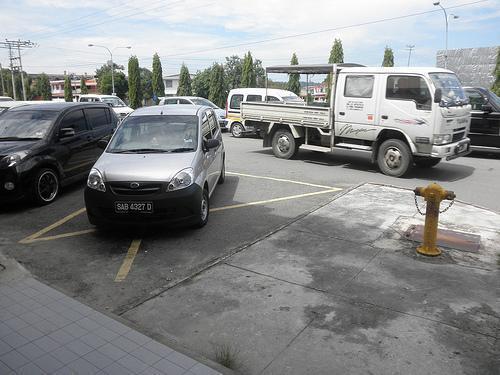How many fire hydrants are there?
Give a very brief answer. 1. How many cars are illegally parked?
Give a very brief answer. 1. 